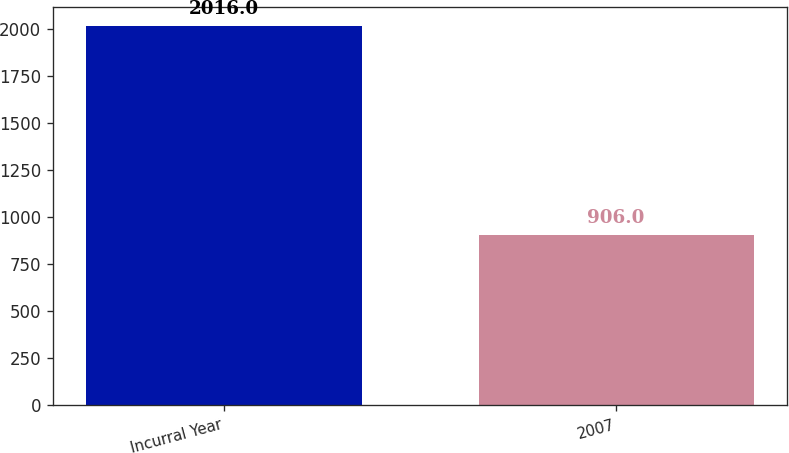<chart> <loc_0><loc_0><loc_500><loc_500><bar_chart><fcel>Incurral Year<fcel>2007<nl><fcel>2016<fcel>906<nl></chart> 